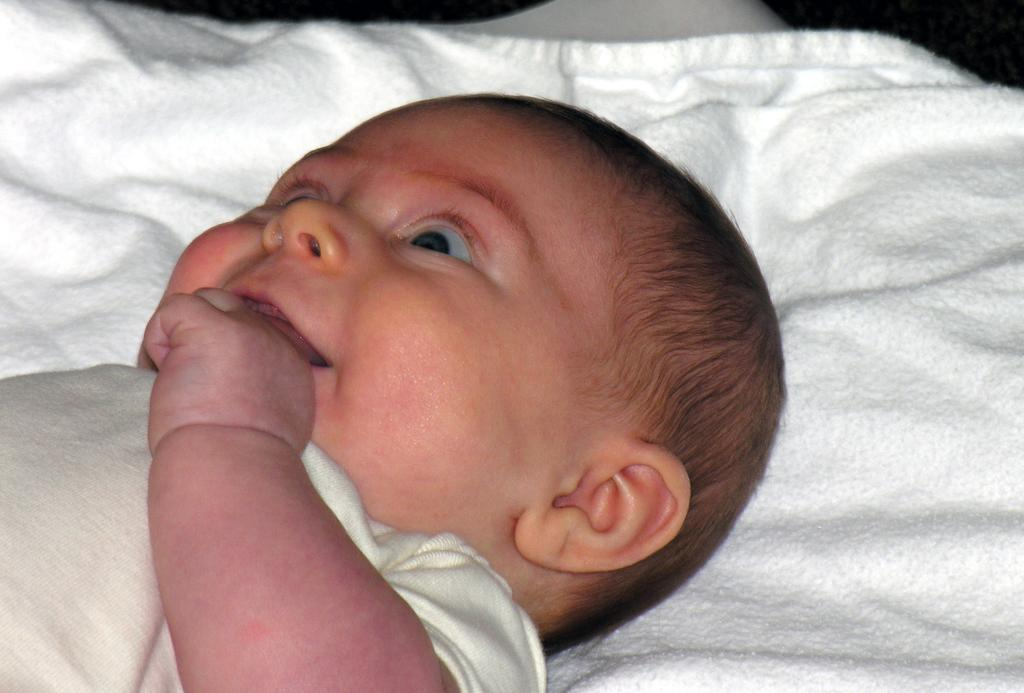What is the main subject of the image? There is a child in the image. What is the child lying on? The child is lying on a white cloth. What color is the background of the image? The background of the image is white. How many pets are visible in the image? There are no pets visible in the image; it features a child lying on a white cloth with a white background. What type of cookware is being used by the child in the image? There is no cookware or cooking activity present in the image; it features a child lying on a white cloth with a white background. 